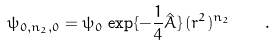Convert formula to latex. <formula><loc_0><loc_0><loc_500><loc_500>\psi _ { 0 , n _ { 2 } , 0 } = \psi _ { 0 } \, \exp \{ - \frac { 1 } { 4 } \hat { A } \} \, ( r ^ { 2 } ) ^ { n _ { 2 } } \quad .</formula> 